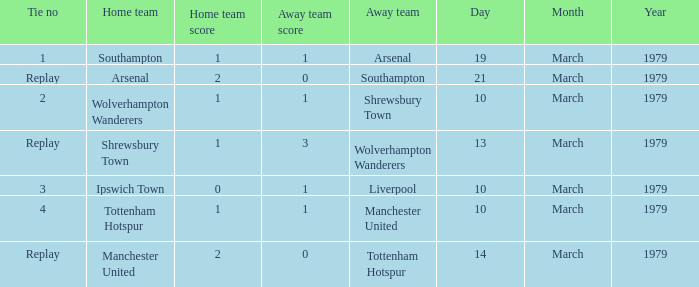Which tie number had an away team of Arsenal? 1.0. 